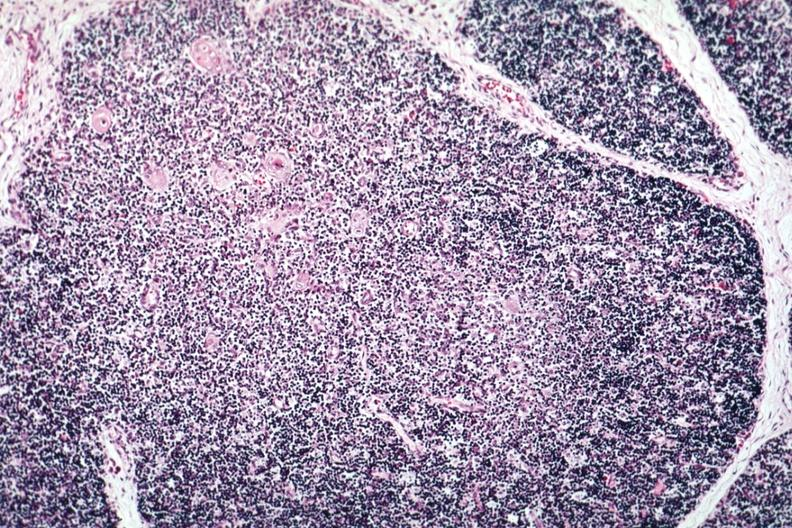s hematologic present?
Answer the question using a single word or phrase. Yes 